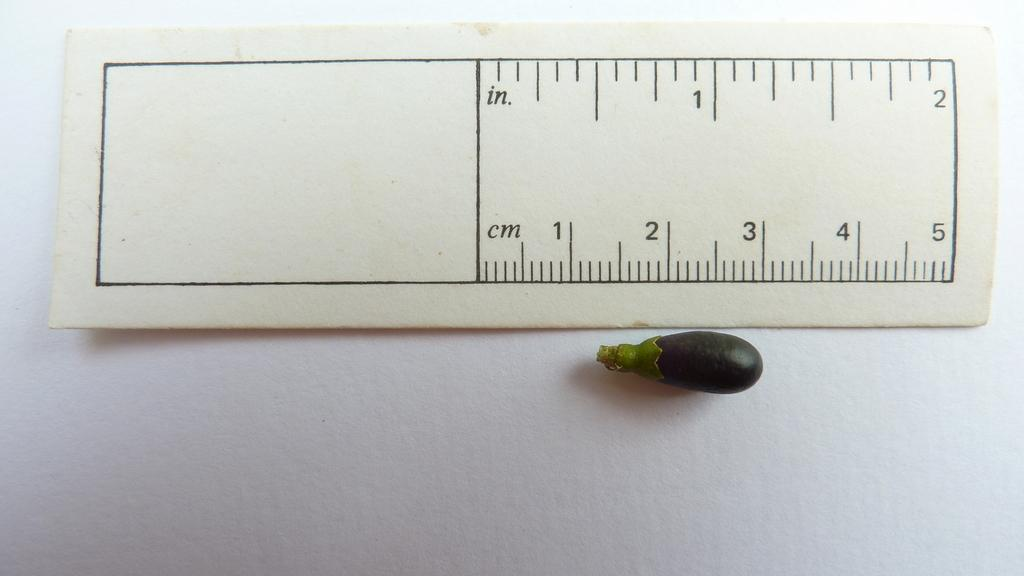<image>
Offer a succinct explanation of the picture presented. Aa ruler displaying centimeters and inches measuring a baby squash 